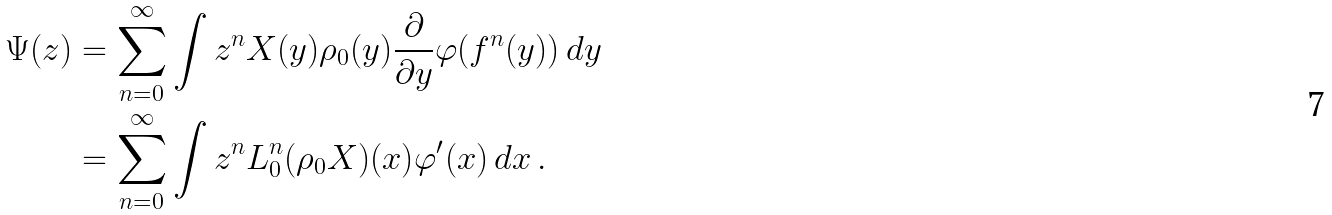<formula> <loc_0><loc_0><loc_500><loc_500>\Psi ( z ) & = \sum _ { n = 0 } ^ { \infty } \int z ^ { n } X ( y ) \rho _ { 0 } ( y ) \frac { \partial } { \partial y } \varphi ( f ^ { n } ( y ) ) \, d y \\ & = \sum _ { n = 0 } ^ { \infty } \int z ^ { n } \L L ^ { n } _ { 0 } ( \rho _ { 0 } X ) ( x ) \varphi ^ { \prime } ( x ) \, d x \, .</formula> 